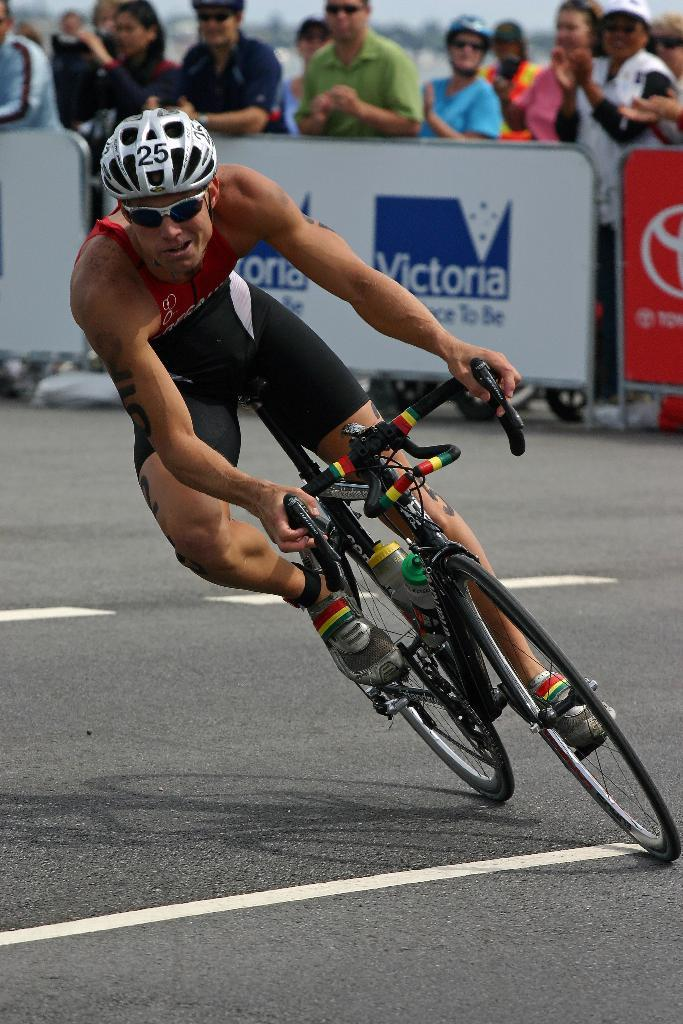What is the man in the image doing? The man in the image is riding a bicycle. Is the man wearing any protective gear in the image? Yes, the man is wearing a helmet in the image. What can be seen in the background of the image? There is a railing in the background of the image. What are the people behind the railing doing? The people behind the railing are encouraging the man riding the bicycle. Can you see any chalk drawings on the ground in the image? There is no mention of chalk drawings in the provided facts, so we cannot determine if they are present in the image. 